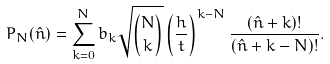Convert formula to latex. <formula><loc_0><loc_0><loc_500><loc_500>P _ { N } ( \hat { n } ) = \sum _ { k = 0 } ^ { N } b _ { k } \sqrt { N \choose k } \left ( \frac { h } { t } \right ) ^ { k - N } \frac { ( \hat { n } + k ) ! } { ( \hat { n } + k - N ) ! } .</formula> 